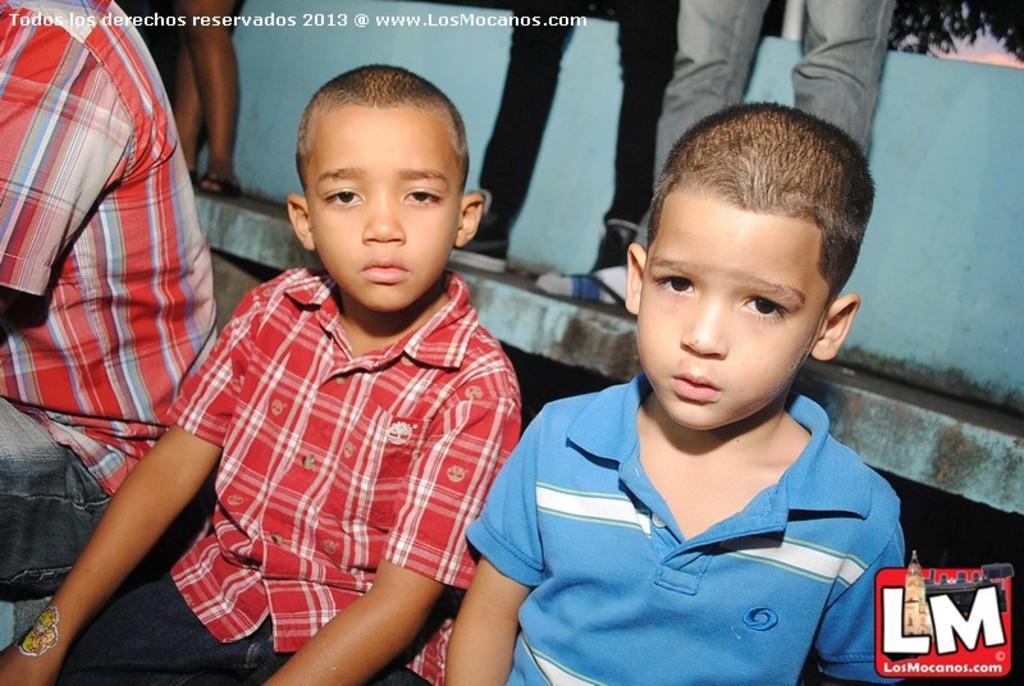In one or two sentences, can you explain what this image depicts? In the foreground of the picture there are two kids. On the left there is a person. In the background there are people, wall and trees. At the bottom towards right there is a logo. 